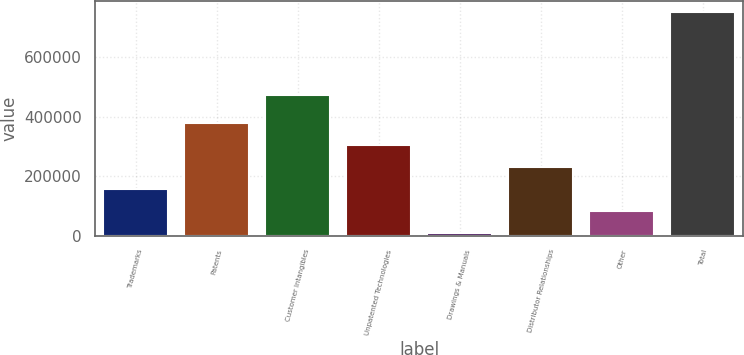Convert chart. <chart><loc_0><loc_0><loc_500><loc_500><bar_chart><fcel>Trademarks<fcel>Patents<fcel>Customer Intangibles<fcel>Unpatented Technologies<fcel>Drawings & Manuals<fcel>Distributor Relationships<fcel>Other<fcel>Total<nl><fcel>156611<fcel>379475<fcel>474309<fcel>305187<fcel>8035<fcel>230899<fcel>82323<fcel>750915<nl></chart> 